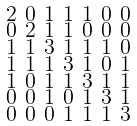<formula> <loc_0><loc_0><loc_500><loc_500>\begin{smallmatrix} 2 & 0 & 1 & 1 & 1 & 0 & 0 \\ 0 & 2 & 1 & 1 & 0 & 0 & 0 \\ 1 & 1 & 3 & 1 & 1 & 1 & 0 \\ 1 & 1 & 1 & 3 & 1 & 0 & 1 \\ 1 & 0 & 1 & 1 & 3 & 1 & 1 \\ 0 & 0 & 1 & 0 & 1 & 3 & 1 \\ 0 & 0 & 0 & 1 & 1 & 1 & 3 \end{smallmatrix}</formula> 